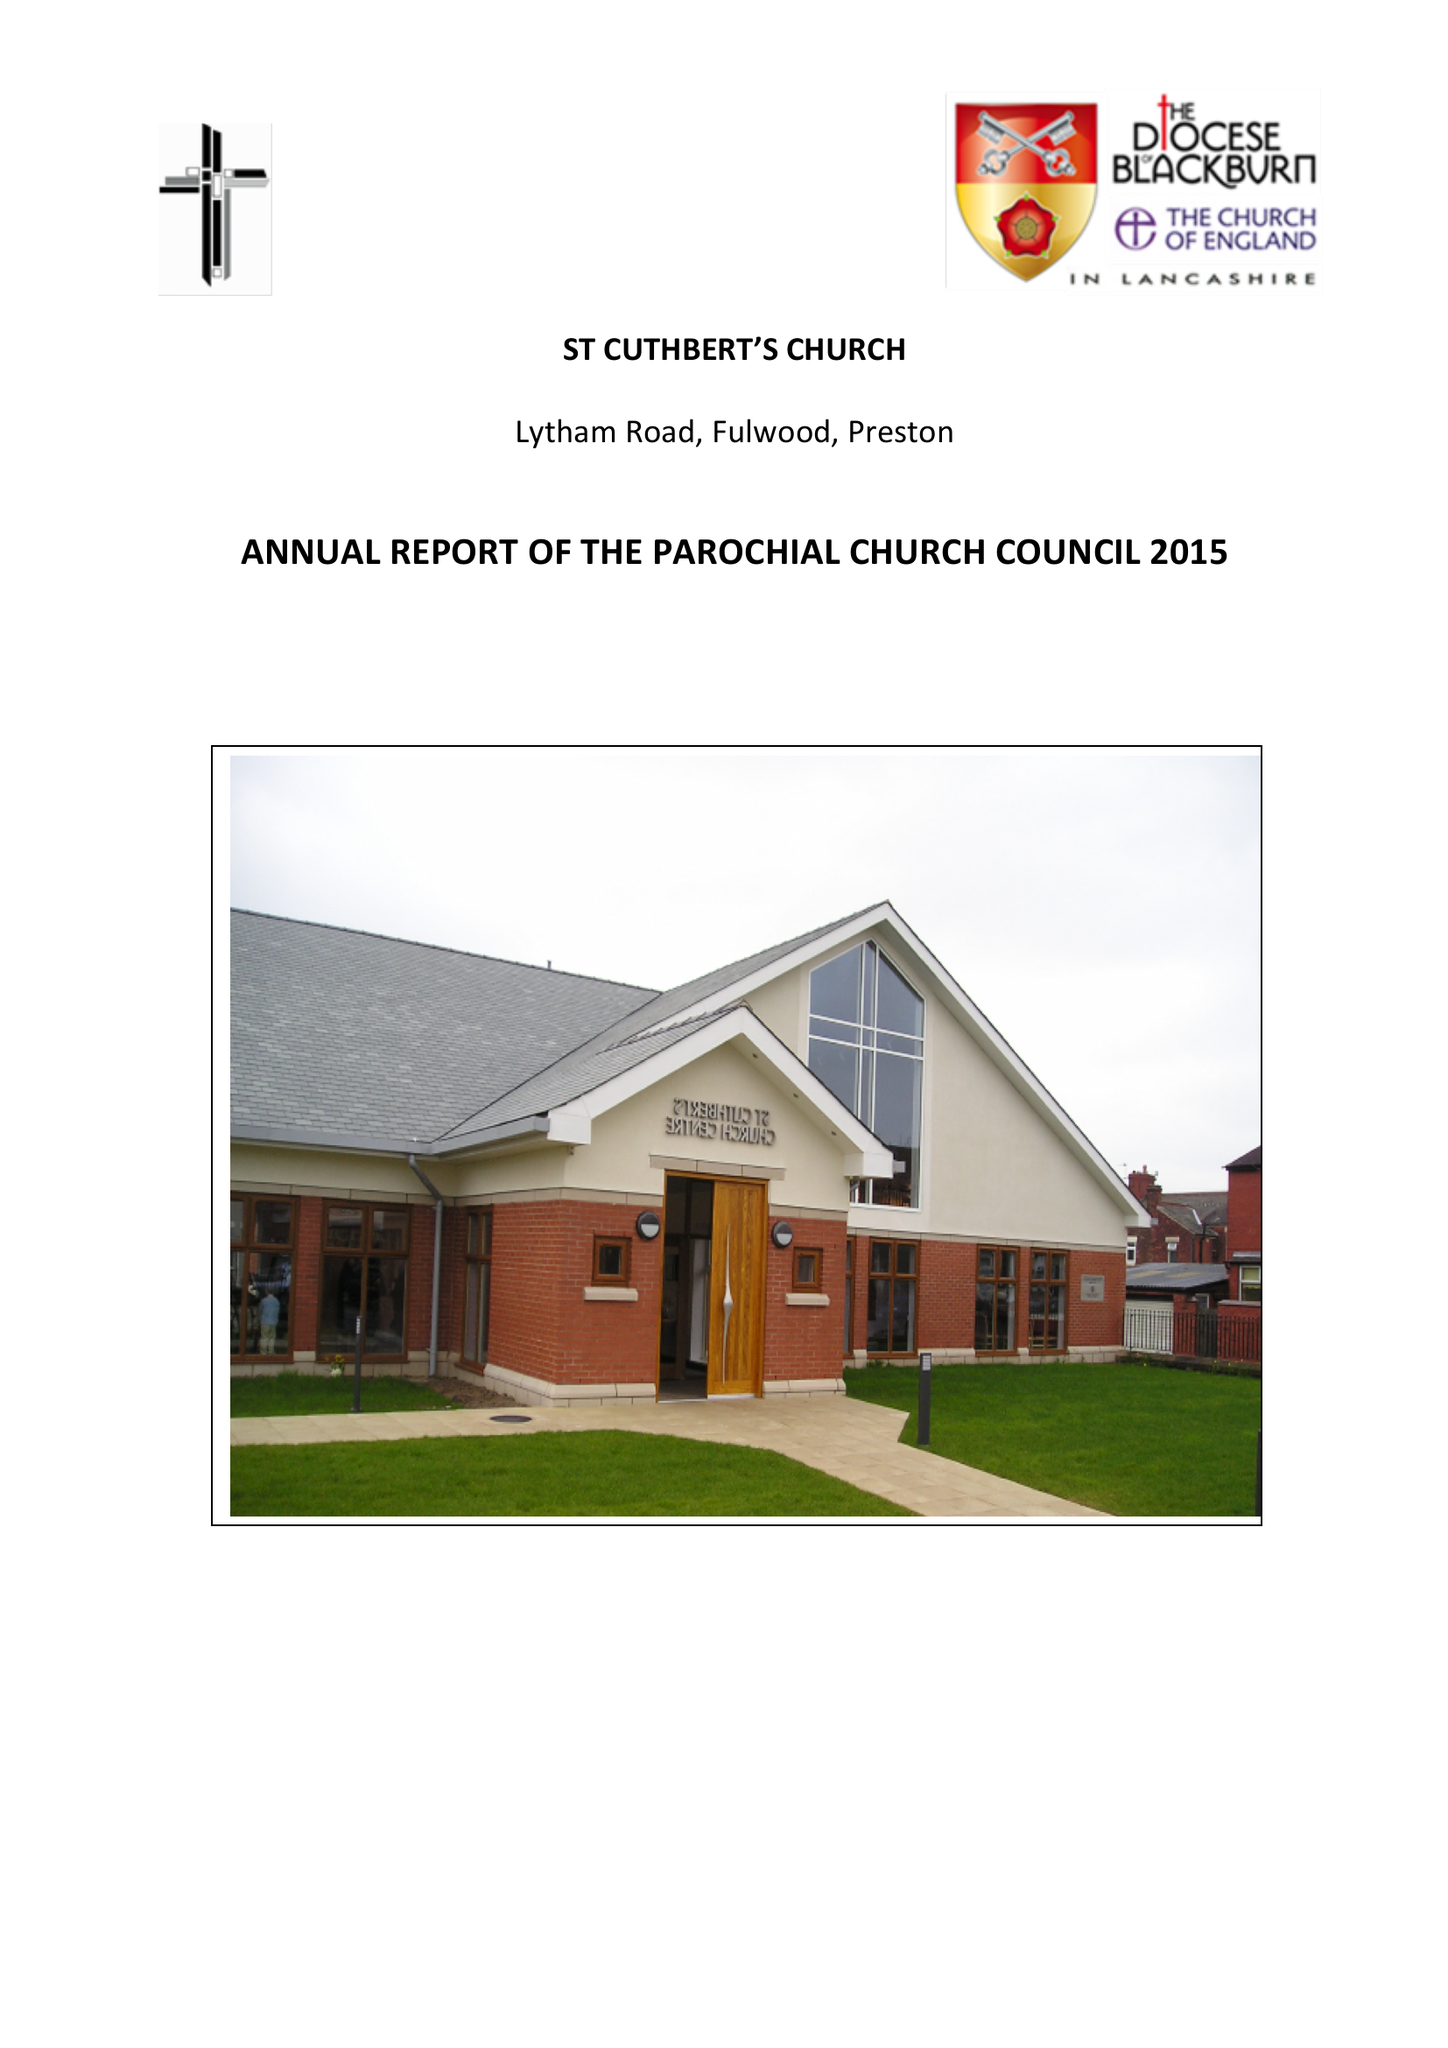What is the value for the address__post_town?
Answer the question using a single word or phrase. PRESTON 